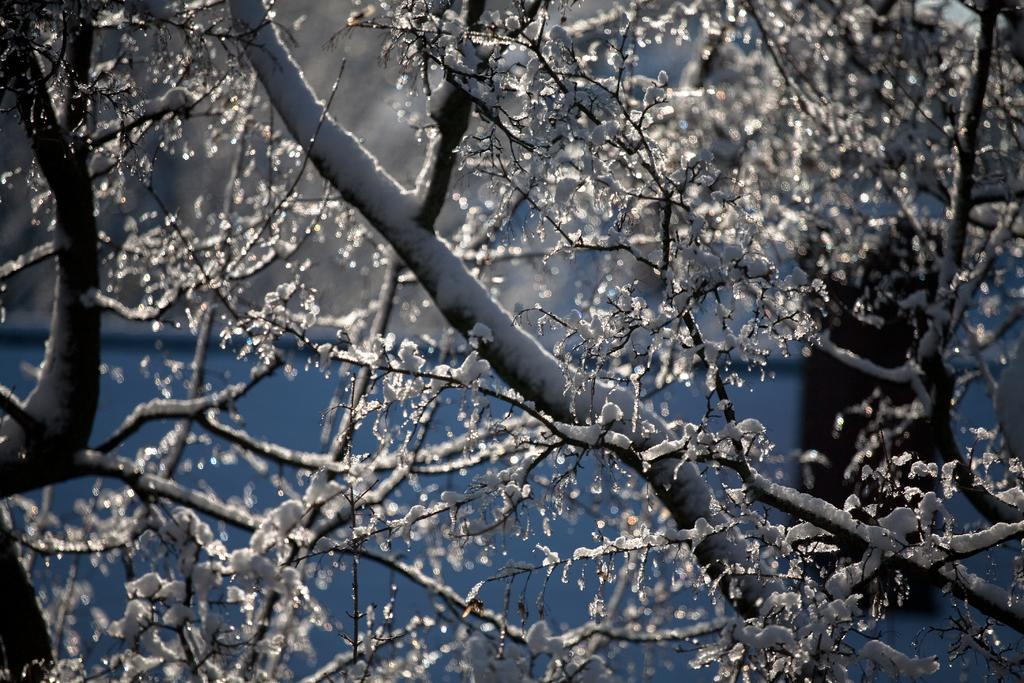What type of vegetation can be seen in the image? There are trees in the image. What is the condition of the trees in the image? The trees are covered with ice. What type of basket is hanging from the trees in the image? There is no basket present in the image; the trees are simply covered with ice. 